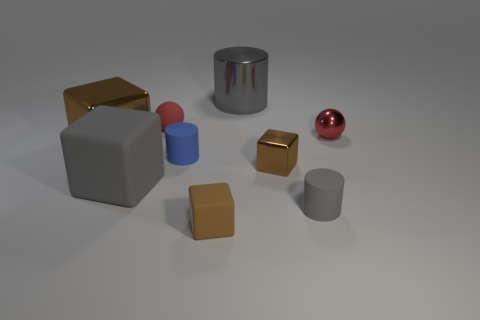How many other small blocks have the same color as the tiny rubber cube?
Ensure brevity in your answer.  1. There is a metallic object that is the same color as the small rubber ball; what is its size?
Keep it short and to the point. Small. What number of metallic objects are the same shape as the brown rubber object?
Give a very brief answer. 2. What material is the small blue object?
Provide a short and direct response. Rubber. There is a small matte sphere; is it the same color as the tiny ball that is right of the small blue rubber cylinder?
Offer a very short reply. Yes. What number of balls are big brown metallic objects or brown matte objects?
Ensure brevity in your answer.  0. There is a small thing that is in front of the small gray matte thing; what is its color?
Your answer should be compact. Brown. There is a object that is the same color as the tiny rubber ball; what is its shape?
Your answer should be very brief. Sphere. How many rubber objects are the same size as the blue rubber cylinder?
Your answer should be compact. 3. There is a large thing behind the red metal ball; is its shape the same as the red thing left of the small blue thing?
Your response must be concise. No. 